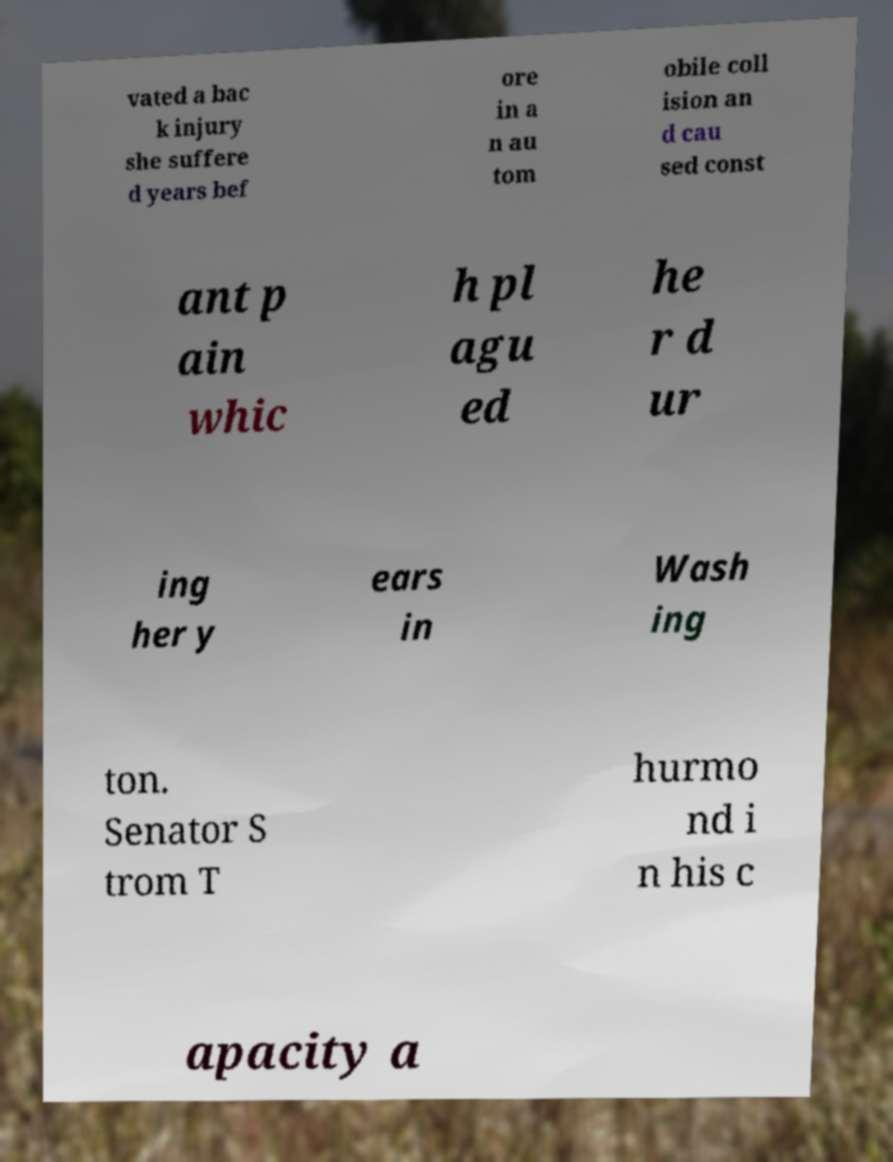What messages or text are displayed in this image? I need them in a readable, typed format. vated a bac k injury she suffere d years bef ore in a n au tom obile coll ision an d cau sed const ant p ain whic h pl agu ed he r d ur ing her y ears in Wash ing ton. Senator S trom T hurmo nd i n his c apacity a 